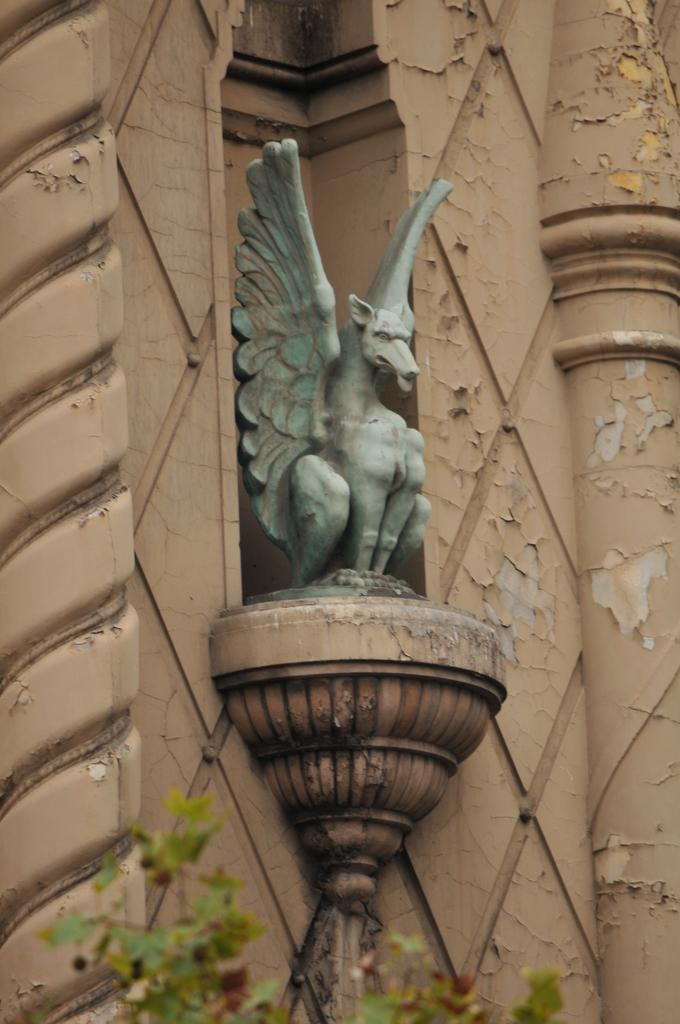What mythical creature is featured in the image? There is a dragon depicted in the image. Where is the dragon located in the image? The dragon is in the middle of the image. What can be seen at the bottom of the image? There are leaves of a tree at the bottom of the image. What type of quartz is the dragon holding in the image? There is no quartz present in the image; the dragon is not holding any object. Is the dragon celebrating a birthday in the image? There is no indication of a birthday celebration in the image. 